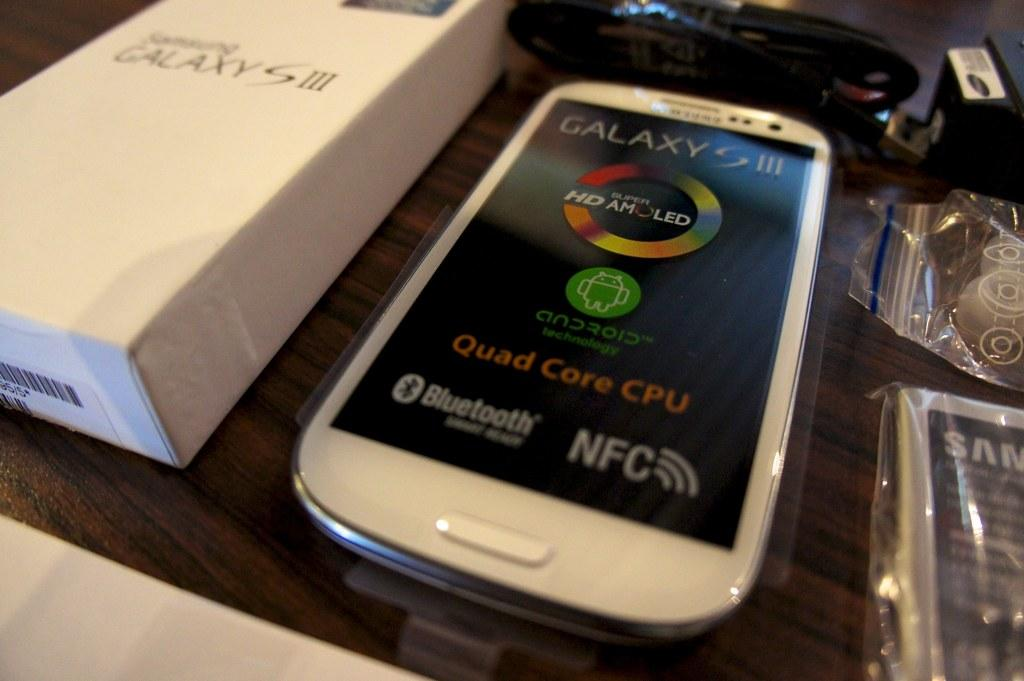<image>
Render a clear and concise summary of the photo. The all new Galaxy S 3, comes in a pretty white along with the box can be yours today. 